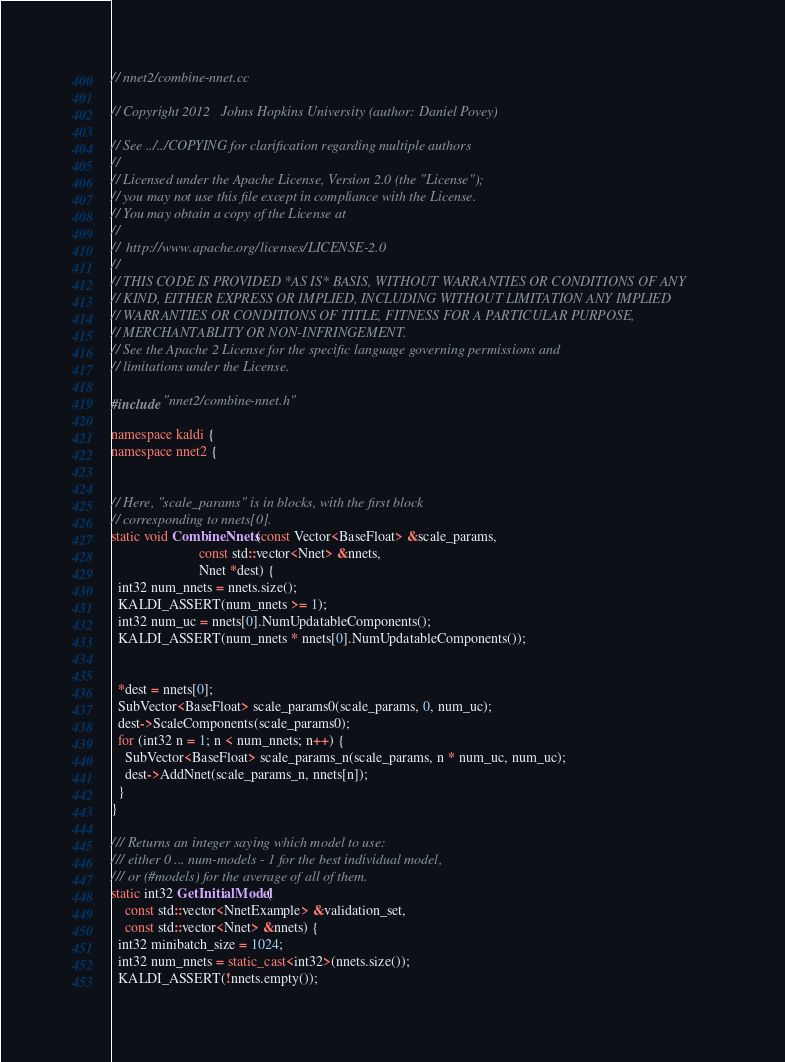Convert code to text. <code><loc_0><loc_0><loc_500><loc_500><_C++_>// nnet2/combine-nnet.cc

// Copyright 2012   Johns Hopkins University (author: Daniel Povey)

// See ../../COPYING for clarification regarding multiple authors
//
// Licensed under the Apache License, Version 2.0 (the "License");
// you may not use this file except in compliance with the License.
// You may obtain a copy of the License at
//
//  http://www.apache.org/licenses/LICENSE-2.0
//
// THIS CODE IS PROVIDED *AS IS* BASIS, WITHOUT WARRANTIES OR CONDITIONS OF ANY
// KIND, EITHER EXPRESS OR IMPLIED, INCLUDING WITHOUT LIMITATION ANY IMPLIED
// WARRANTIES OR CONDITIONS OF TITLE, FITNESS FOR A PARTICULAR PURPOSE,
// MERCHANTABLITY OR NON-INFRINGEMENT.
// See the Apache 2 License for the specific language governing permissions and
// limitations under the License.

#include "nnet2/combine-nnet.h"

namespace kaldi {
namespace nnet2 {


// Here, "scale_params" is in blocks, with the first block
// corresponding to nnets[0].
static void CombineNnets(const Vector<BaseFloat> &scale_params,
                         const std::vector<Nnet> &nnets,
                         Nnet *dest) {
  int32 num_nnets = nnets.size();
  KALDI_ASSERT(num_nnets >= 1);
  int32 num_uc = nnets[0].NumUpdatableComponents();
  KALDI_ASSERT(num_nnets * nnets[0].NumUpdatableComponents());
  
  
  *dest = nnets[0];
  SubVector<BaseFloat> scale_params0(scale_params, 0, num_uc);
  dest->ScaleComponents(scale_params0);
  for (int32 n = 1; n < num_nnets; n++) {
    SubVector<BaseFloat> scale_params_n(scale_params, n * num_uc, num_uc);
    dest->AddNnet(scale_params_n, nnets[n]);
  }
}

/// Returns an integer saying which model to use:
/// either 0 ... num-models - 1 for the best individual model,
/// or (#models) for the average of all of them.
static int32 GetInitialModel(
    const std::vector<NnetExample> &validation_set,
    const std::vector<Nnet> &nnets) {
  int32 minibatch_size = 1024;
  int32 num_nnets = static_cast<int32>(nnets.size());
  KALDI_ASSERT(!nnets.empty());</code> 